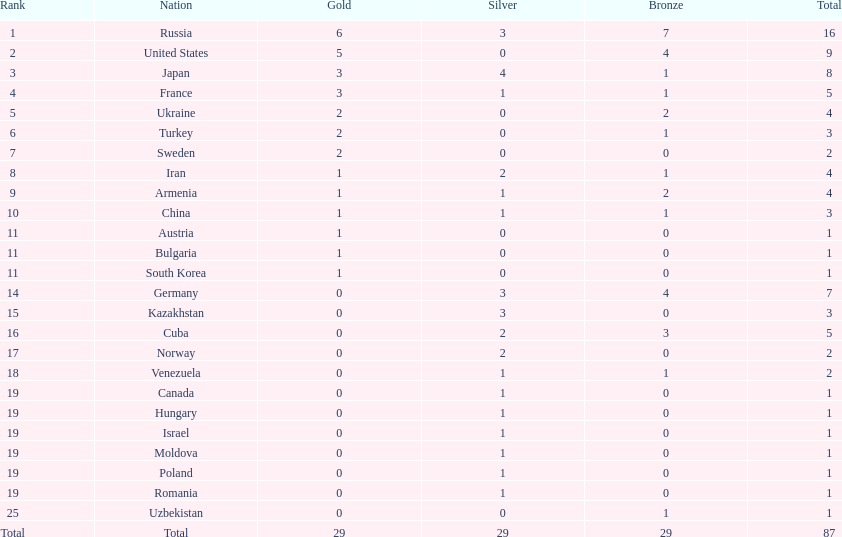What is the count of nations that have earned more than 5 bronze medals? 1. 